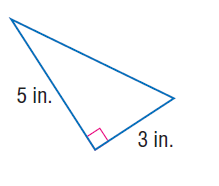Question: Use the Pythagorean Theorem to find the length of the hypotenuse of the right triangle.
Choices:
A. 3
B. 4
C. 5
D. \sqrt { 34 }
Answer with the letter. Answer: D 